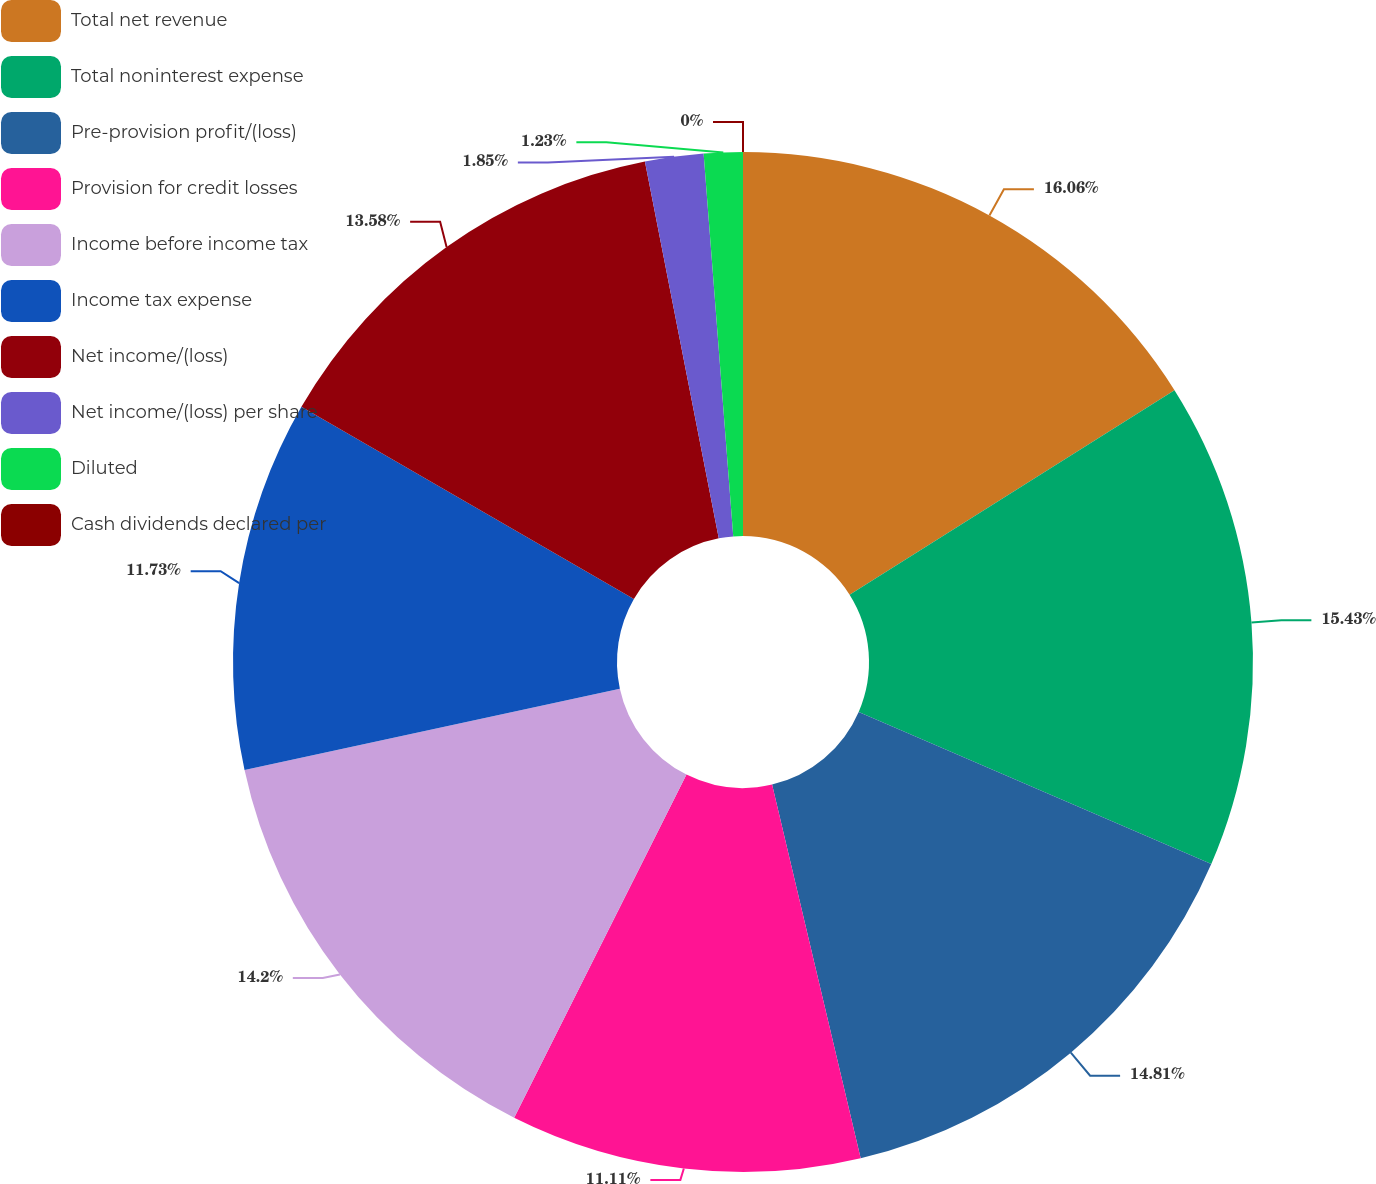Convert chart. <chart><loc_0><loc_0><loc_500><loc_500><pie_chart><fcel>Total net revenue<fcel>Total noninterest expense<fcel>Pre-provision profit/(loss)<fcel>Provision for credit losses<fcel>Income before income tax<fcel>Income tax expense<fcel>Net income/(loss)<fcel>Net income/(loss) per share<fcel>Diluted<fcel>Cash dividends declared per<nl><fcel>16.05%<fcel>15.43%<fcel>14.81%<fcel>11.11%<fcel>14.2%<fcel>11.73%<fcel>13.58%<fcel>1.85%<fcel>1.23%<fcel>0.0%<nl></chart> 